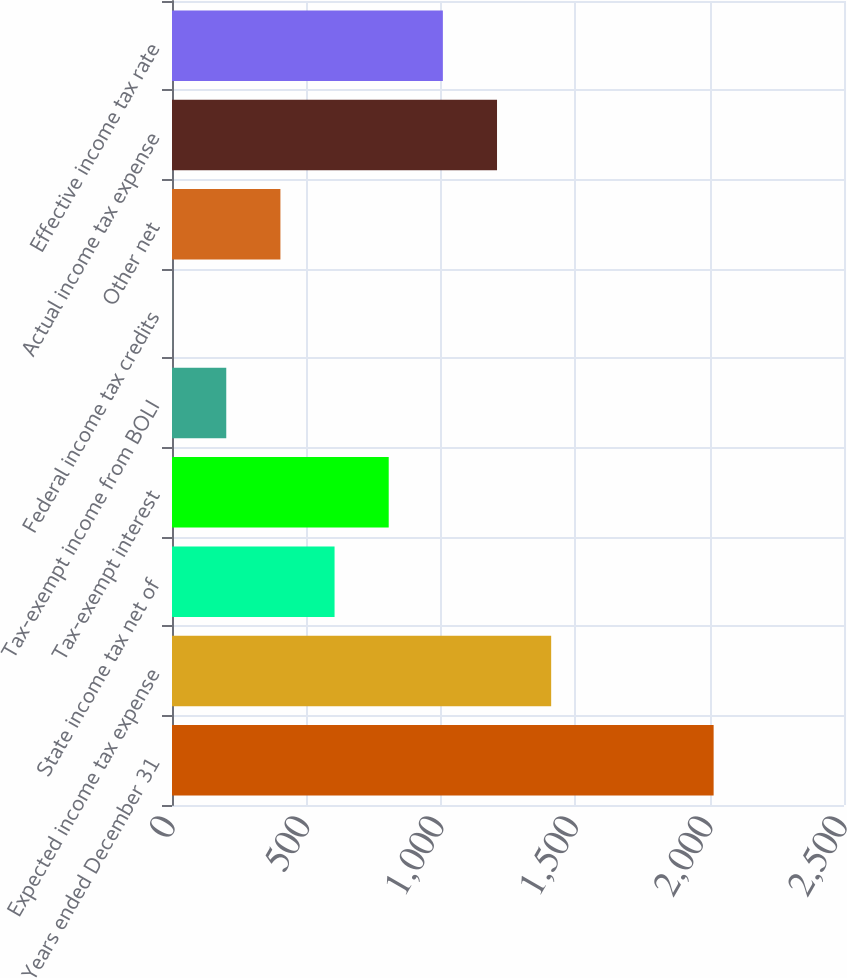Convert chart. <chart><loc_0><loc_0><loc_500><loc_500><bar_chart><fcel>Years ended December 31<fcel>Expected income tax expense<fcel>State income tax net of<fcel>Tax-exempt interest<fcel>Tax-exempt income from BOLI<fcel>Federal income tax credits<fcel>Other net<fcel>Actual income tax expense<fcel>Effective income tax rate<nl><fcel>2015<fcel>1410.62<fcel>604.78<fcel>806.24<fcel>201.86<fcel>0.4<fcel>403.32<fcel>1209.16<fcel>1007.7<nl></chart> 